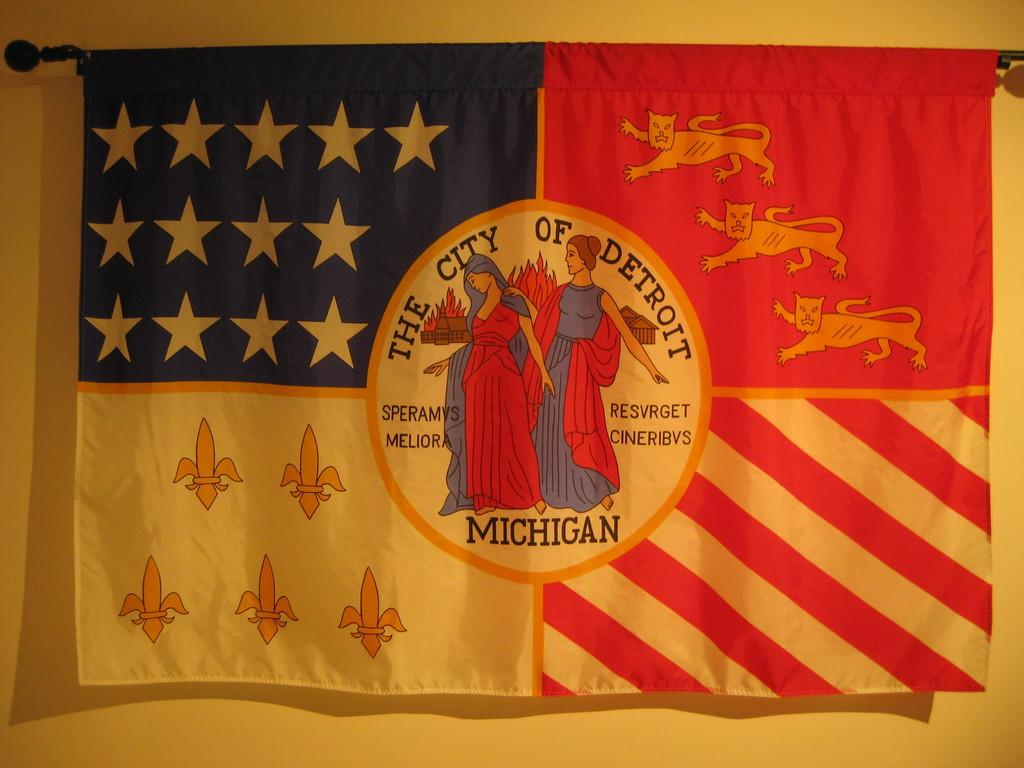What is the main object in the image? There is a flag in the image. What is depicted on the flag? The flag has a picture of two women. What can be seen in the background of the image? There is a wall in the background of the image. What type of soap is being used to cover the flag in the image? There is no soap or covering present in the image; it features a flag with a picture of two women in front of a wall. 